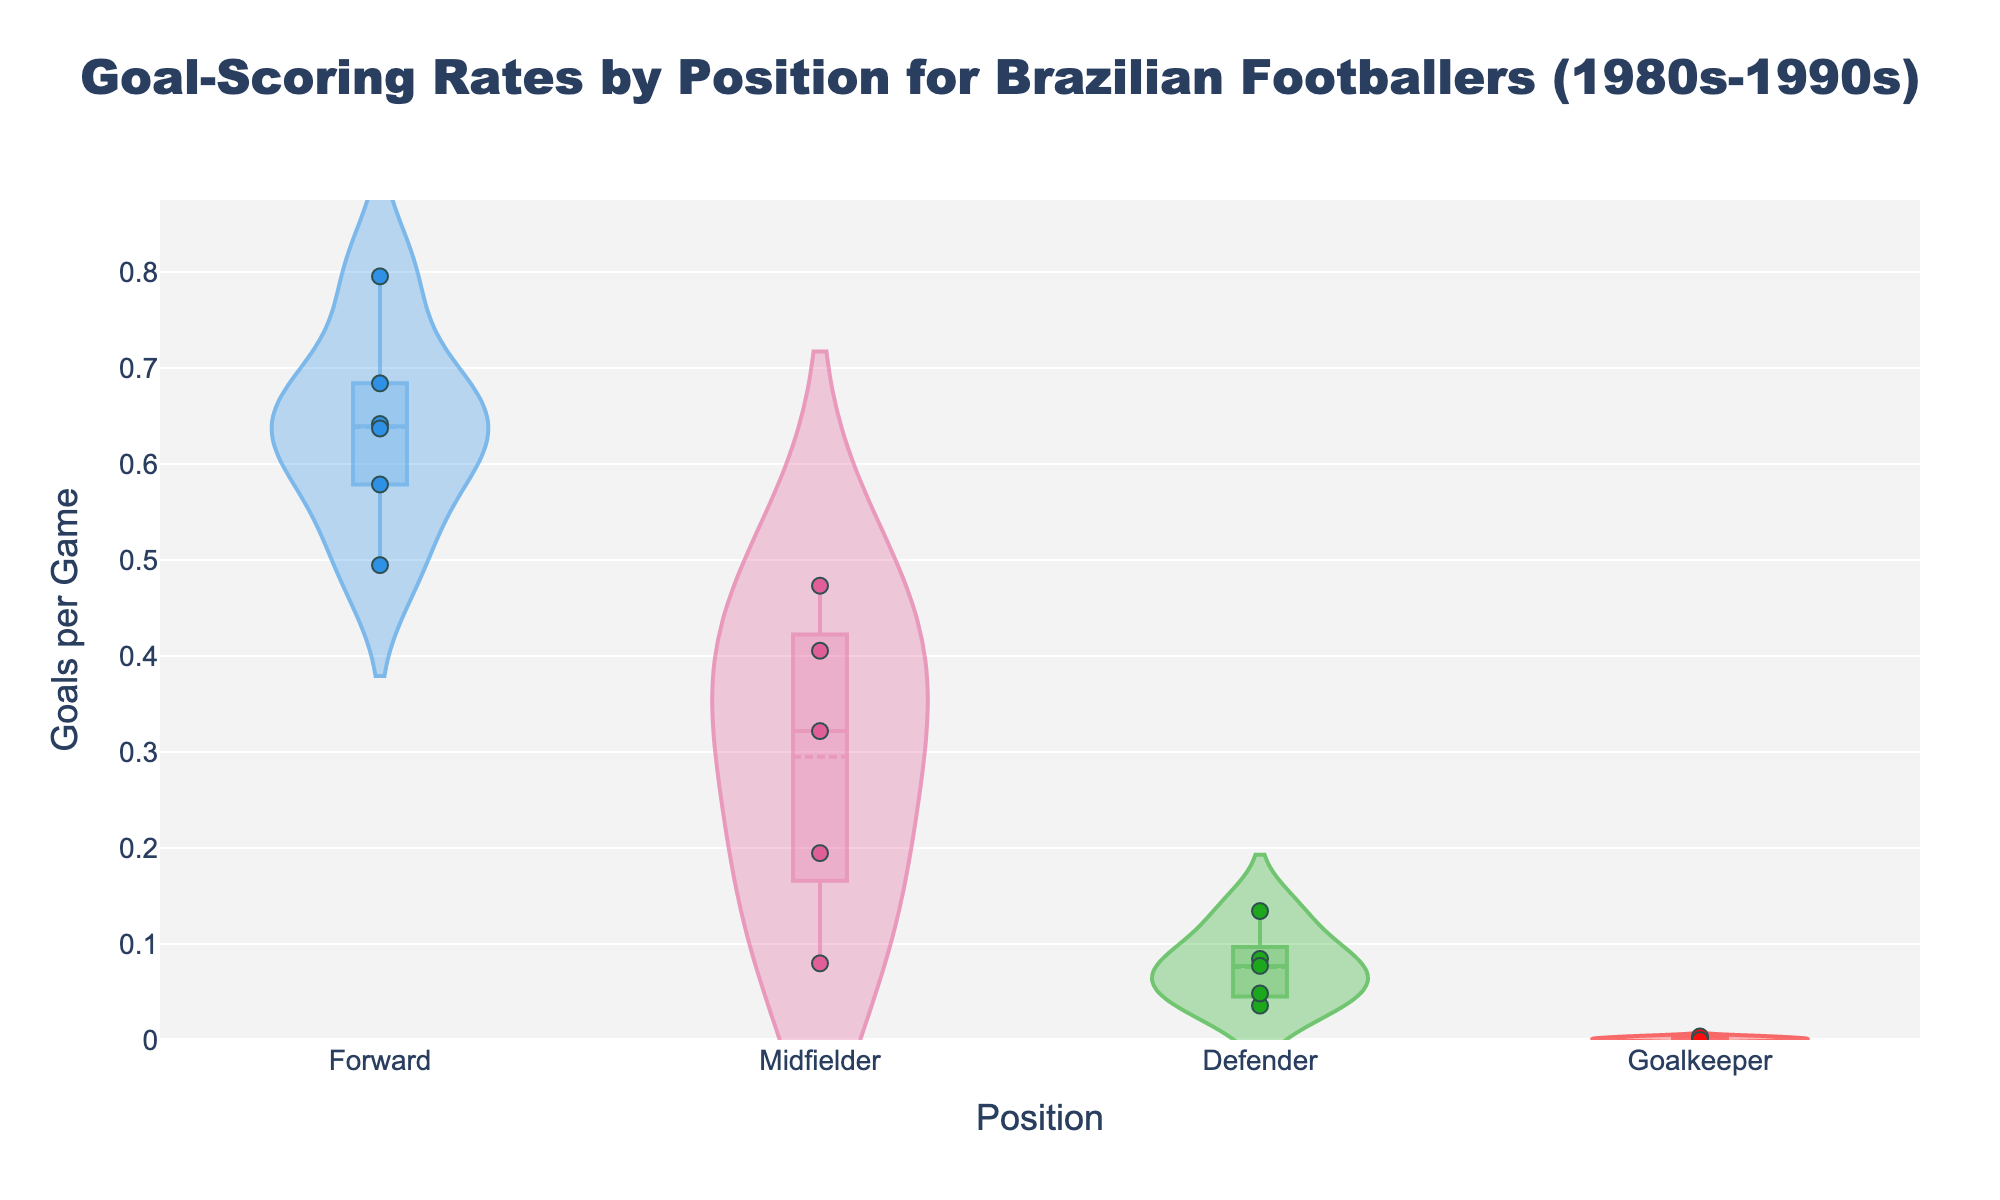How many positions are compared in the figure? Look at the x-axis labels to see the different positions plotted in the violin chart.
Answer: 5 What's the title of the chart? The title is typically located at the top center of the chart.
Answer: "Goal-Scoring Rates by Position for Brazilian Footballers (1980s-1990s)" Which position has the highest median goals per game? Identify the position whose violin plot has the median line (dashed line or middle of the box) set at the highest value on the y-axis.
Answer: Forward What is the range of the goalkeeper's goals per game? Look at the violin plot for the Goalkeeper position on the x-axis and find the range of values on the y-axis this plot covers.
Answer: 0 to 0.004 Between Forwards and Midfielders, which position shows more variability in goals per game? Compare the width and spread of the violin plots for Forwards and Midfielders. The wider and more spread out the plot, the greater the variability.
Answer: Forward How many players are included in the analysis for defenders? Count the number of jittered points in the Defender's section of the x-axis.
Answer: 4 Who is the forward with the highest goals per game rate? Hover over the scatter points in the Forward section and identify the name with the highest y-value.
Answer: Romário Is the average goals per game for midfielders greater in the 1980s or 1990s? Compare the meanline (or the central box depending on chart's details) positions for midfielders from two different decades. This involves looking at players from the 1980s and the 1990s within the Midfielder position.
Answer: 1990s Do goalkeepers show any significant goal-scoring capabilities based on the chart? Examine the violin and scatter points for the Goalkeeper position to see if their goals per game rates exceed negligible values on the y-axis.
Answer: No How does the data of Defenders compare against Midfielders in terms of spread? Analyze the width and height of the violin plots for Defenders and Midfielders on the x-axis to compare their spread in goals per game.
Answer: Midfielders have a wider spread 